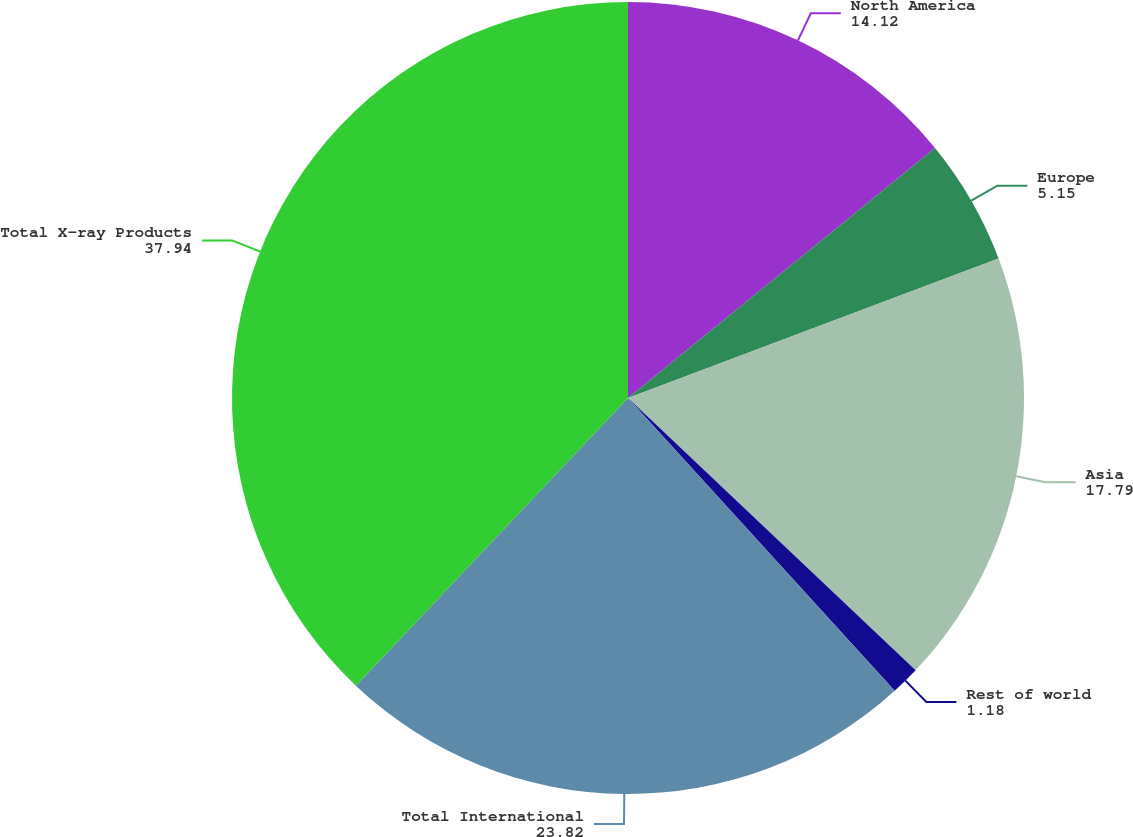Convert chart. <chart><loc_0><loc_0><loc_500><loc_500><pie_chart><fcel>North America<fcel>Europe<fcel>Asia<fcel>Rest of world<fcel>Total International<fcel>Total X-ray Products<nl><fcel>14.12%<fcel>5.15%<fcel>17.79%<fcel>1.18%<fcel>23.82%<fcel>37.94%<nl></chart> 